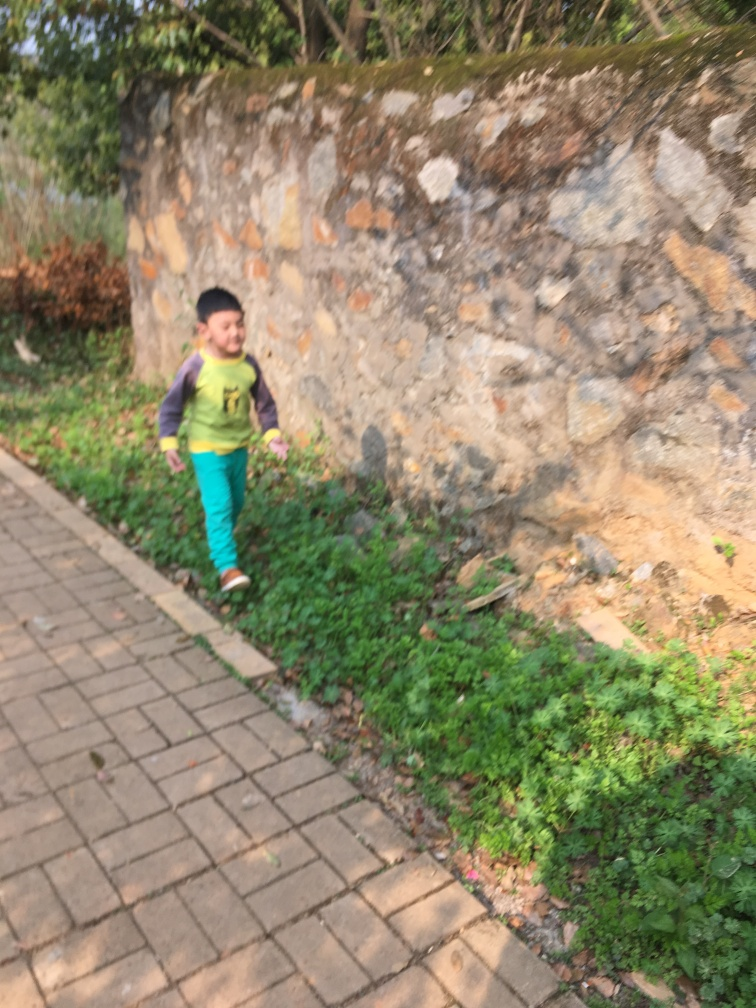Can you describe the setting in which this photo was taken? The photo was taken outdoors, with a stone wall that has elements of wear and moss growth indicating it might be an older structure. The ground is laid with regular paving blocks, hinting at a maintained pathway, possibly in a park or garden area. What time of day does the lighting suggest? Given the soft shadows and the warm tone of the light, it appears that the photo might have been taken during the late afternoon, often referred to as the 'golden hour' in photography, which is known for its warm, diffused light. 